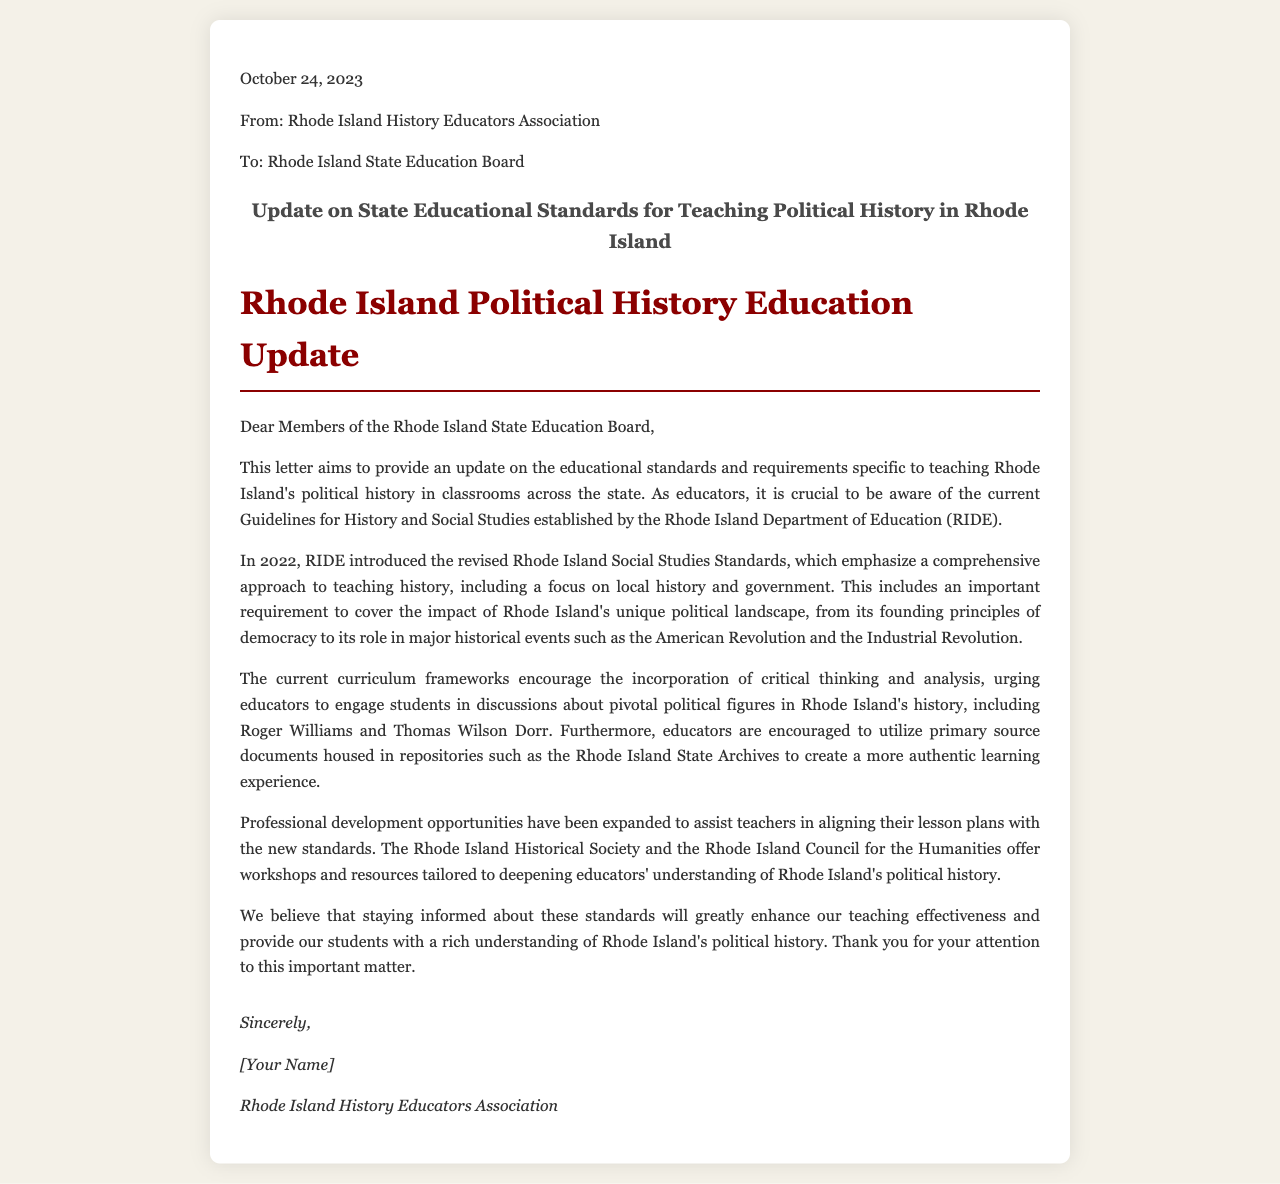What is the date of the letter? The letter is dated October 24, 2023.
Answer: October 24, 2023 Who is the sender of the letter? The letter is sent from the Rhode Island History Educators Association.
Answer: Rhode Island History Educators Association What curriculum guidelines were revised in 2022? The Rhode Island Social Studies Standards were revised in 2022.
Answer: Rhode Island Social Studies Standards What are educators encouraged to utilize for teaching? Educators are encouraged to utilize primary source documents.
Answer: primary source documents Which two political figures are mentioned in the letter? The letter mentions Roger Williams and Thomas Wilson Dorr.
Answer: Roger Williams and Thomas Wilson Dorr What is emphasized in the new Social Studies Standards? A comprehensive approach to teaching history is emphasized.
Answer: comprehensive approach What organization offers professional development workshops? The Rhode Island Historical Society offers workshops.
Answer: Rhode Island Historical Society What type of experience are educators encouraged to create? Educators are encouraged to create an authentic learning experience.
Answer: authentic learning experience 